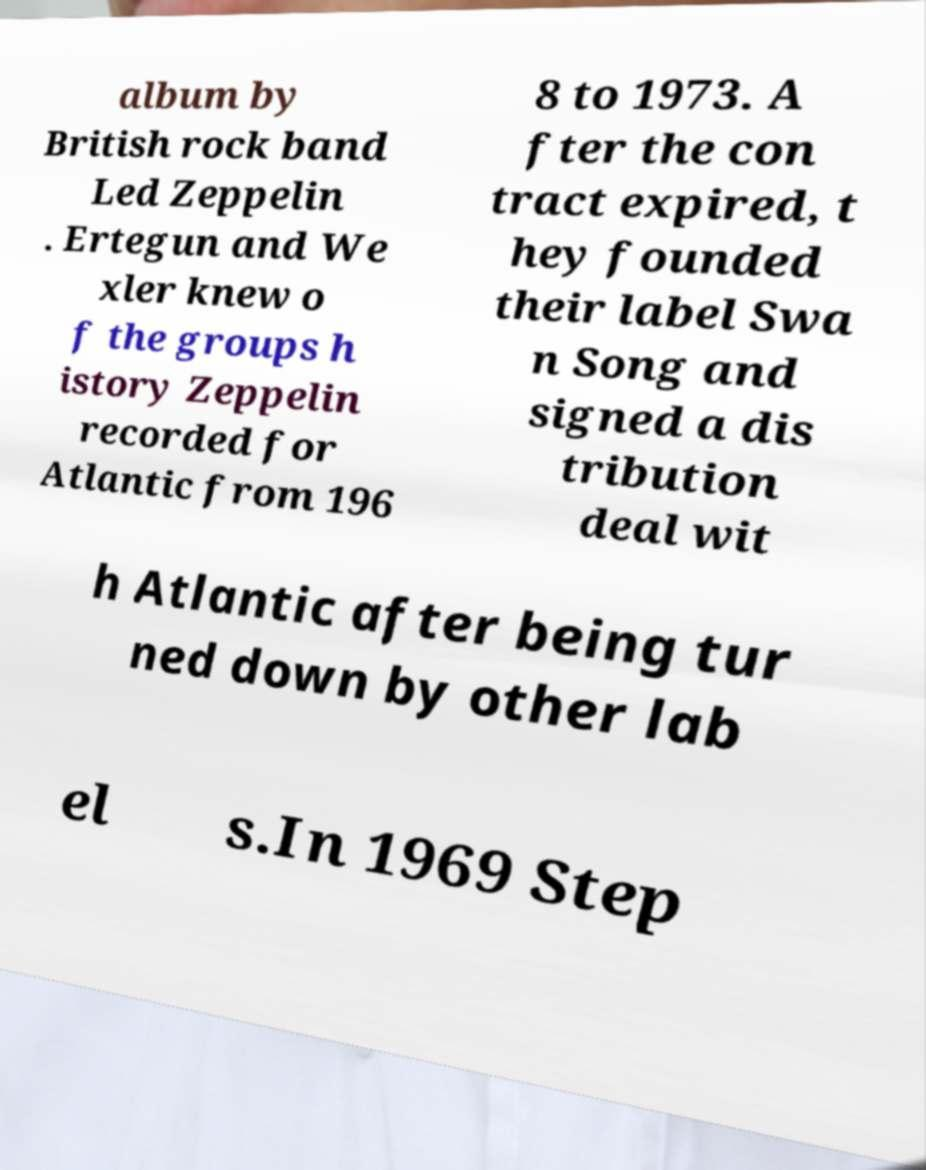There's text embedded in this image that I need extracted. Can you transcribe it verbatim? album by British rock band Led Zeppelin . Ertegun and We xler knew o f the groups h istory Zeppelin recorded for Atlantic from 196 8 to 1973. A fter the con tract expired, t hey founded their label Swa n Song and signed a dis tribution deal wit h Atlantic after being tur ned down by other lab el s.In 1969 Step 